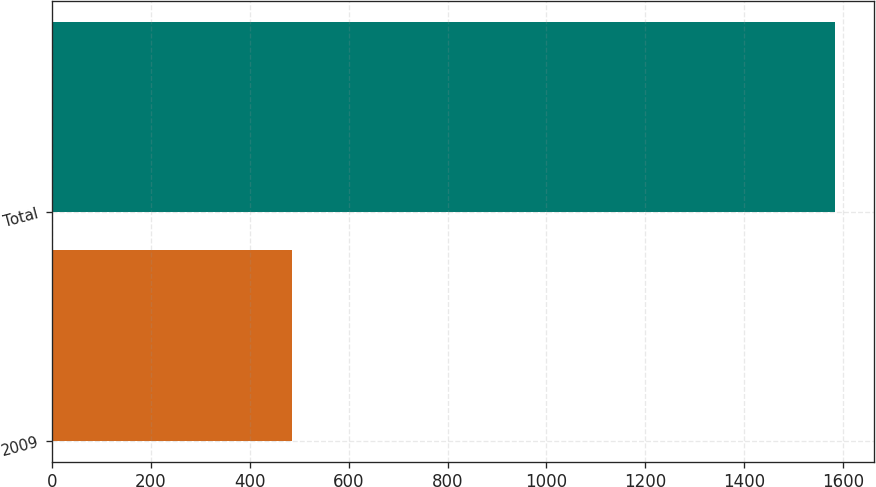<chart> <loc_0><loc_0><loc_500><loc_500><bar_chart><fcel>2009<fcel>Total<nl><fcel>486<fcel>1584<nl></chart> 